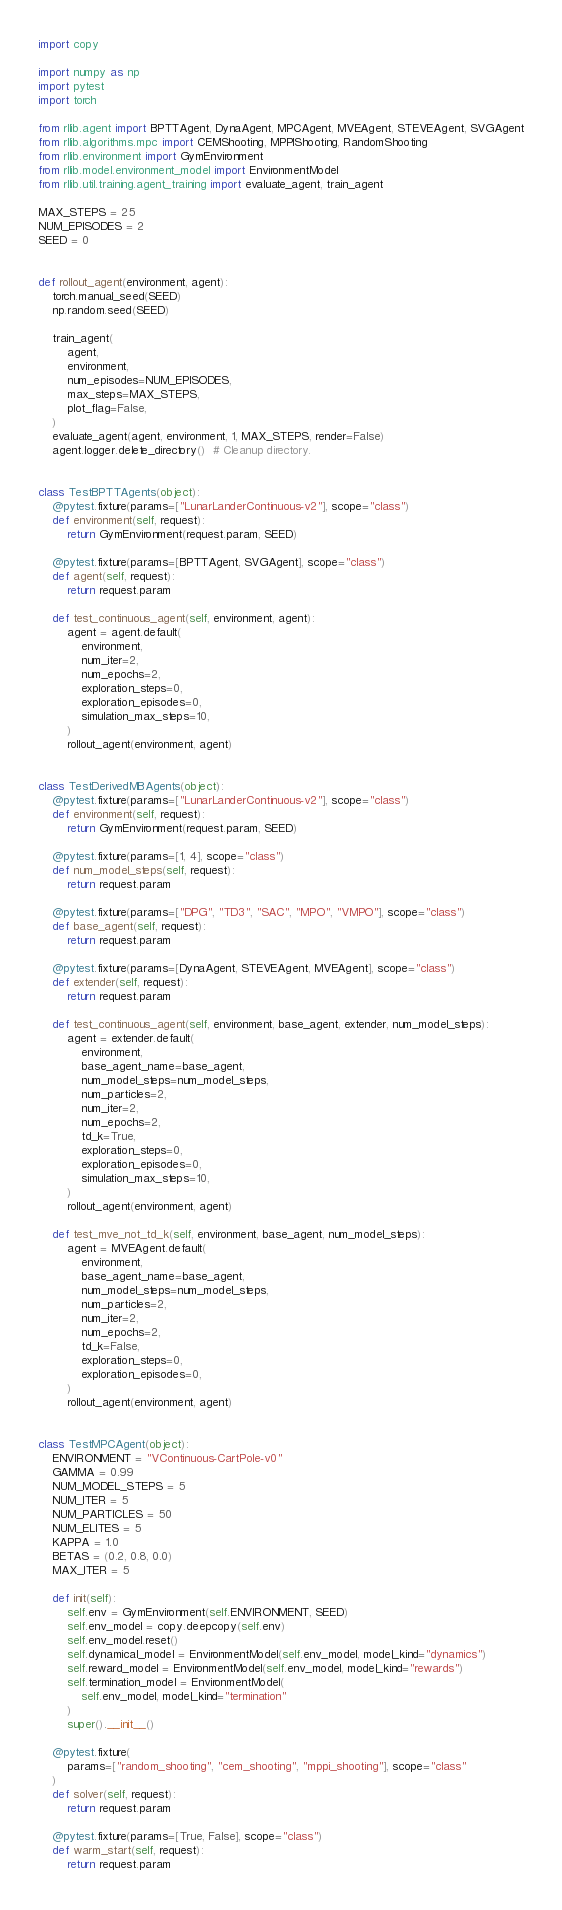Convert code to text. <code><loc_0><loc_0><loc_500><loc_500><_Python_>import copy

import numpy as np
import pytest
import torch

from rllib.agent import BPTTAgent, DynaAgent, MPCAgent, MVEAgent, STEVEAgent, SVGAgent
from rllib.algorithms.mpc import CEMShooting, MPPIShooting, RandomShooting
from rllib.environment import GymEnvironment
from rllib.model.environment_model import EnvironmentModel
from rllib.util.training.agent_training import evaluate_agent, train_agent

MAX_STEPS = 25
NUM_EPISODES = 2
SEED = 0


def rollout_agent(environment, agent):
    torch.manual_seed(SEED)
    np.random.seed(SEED)

    train_agent(
        agent,
        environment,
        num_episodes=NUM_EPISODES,
        max_steps=MAX_STEPS,
        plot_flag=False,
    )
    evaluate_agent(agent, environment, 1, MAX_STEPS, render=False)
    agent.logger.delete_directory()  # Cleanup directory.


class TestBPTTAgents(object):
    @pytest.fixture(params=["LunarLanderContinuous-v2"], scope="class")
    def environment(self, request):
        return GymEnvironment(request.param, SEED)

    @pytest.fixture(params=[BPTTAgent, SVGAgent], scope="class")
    def agent(self, request):
        return request.param

    def test_continuous_agent(self, environment, agent):
        agent = agent.default(
            environment,
            num_iter=2,
            num_epochs=2,
            exploration_steps=0,
            exploration_episodes=0,
            simulation_max_steps=10,
        )
        rollout_agent(environment, agent)


class TestDerivedMBAgents(object):
    @pytest.fixture(params=["LunarLanderContinuous-v2"], scope="class")
    def environment(self, request):
        return GymEnvironment(request.param, SEED)

    @pytest.fixture(params=[1, 4], scope="class")
    def num_model_steps(self, request):
        return request.param

    @pytest.fixture(params=["DPG", "TD3", "SAC", "MPO", "VMPO"], scope="class")
    def base_agent(self, request):
        return request.param

    @pytest.fixture(params=[DynaAgent, STEVEAgent, MVEAgent], scope="class")
    def extender(self, request):
        return request.param

    def test_continuous_agent(self, environment, base_agent, extender, num_model_steps):
        agent = extender.default(
            environment,
            base_agent_name=base_agent,
            num_model_steps=num_model_steps,
            num_particles=2,
            num_iter=2,
            num_epochs=2,
            td_k=True,
            exploration_steps=0,
            exploration_episodes=0,
            simulation_max_steps=10,
        )
        rollout_agent(environment, agent)

    def test_mve_not_td_k(self, environment, base_agent, num_model_steps):
        agent = MVEAgent.default(
            environment,
            base_agent_name=base_agent,
            num_model_steps=num_model_steps,
            num_particles=2,
            num_iter=2,
            num_epochs=2,
            td_k=False,
            exploration_steps=0,
            exploration_episodes=0,
        )
        rollout_agent(environment, agent)


class TestMPCAgent(object):
    ENVIRONMENT = "VContinuous-CartPole-v0"
    GAMMA = 0.99
    NUM_MODEL_STEPS = 5
    NUM_ITER = 5
    NUM_PARTICLES = 50
    NUM_ELITES = 5
    KAPPA = 1.0
    BETAS = (0.2, 0.8, 0.0)
    MAX_ITER = 5

    def init(self):
        self.env = GymEnvironment(self.ENVIRONMENT, SEED)
        self.env_model = copy.deepcopy(self.env)
        self.env_model.reset()
        self.dynamical_model = EnvironmentModel(self.env_model, model_kind="dynamics")
        self.reward_model = EnvironmentModel(self.env_model, model_kind="rewards")
        self.termination_model = EnvironmentModel(
            self.env_model, model_kind="termination"
        )
        super().__init__()

    @pytest.fixture(
        params=["random_shooting", "cem_shooting", "mppi_shooting"], scope="class"
    )
    def solver(self, request):
        return request.param

    @pytest.fixture(params=[True, False], scope="class")
    def warm_start(self, request):
        return request.param
</code> 